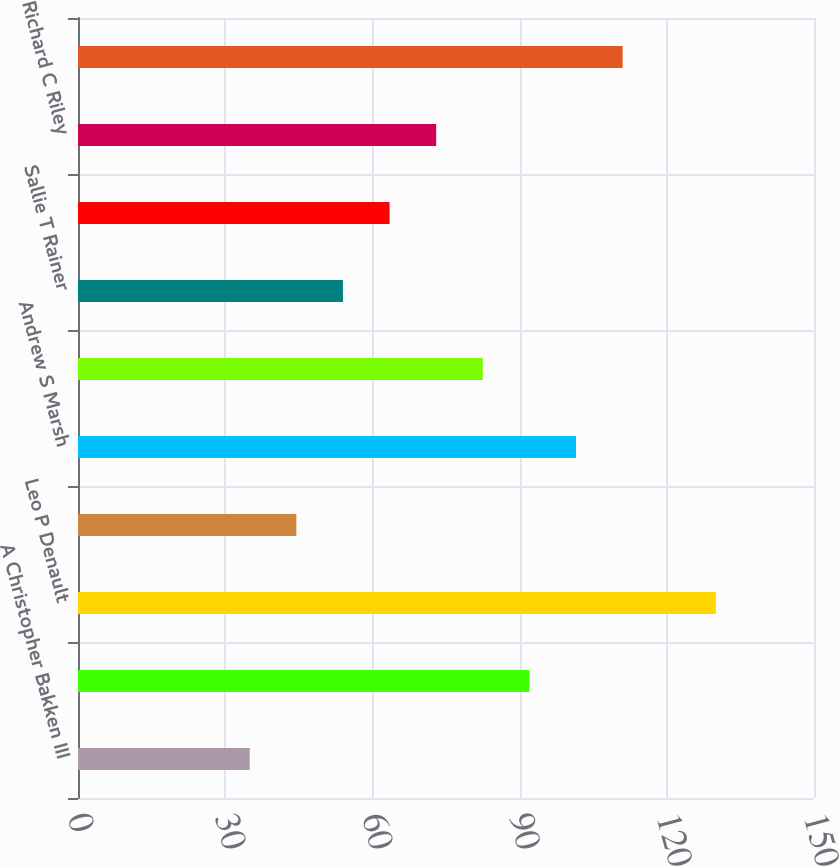Convert chart to OTSL. <chart><loc_0><loc_0><loc_500><loc_500><bar_chart><fcel>A Christopher Bakken III<fcel>Marcus V Brown<fcel>Leo P Denault<fcel>Haley R Fisackerly<fcel>Andrew S Marsh<fcel>Phillip R May Jr<fcel>Sallie T Rainer<fcel>Charles L Rice Jr<fcel>Richard C Riley<fcel>Roderick K West<nl><fcel>35<fcel>92<fcel>130<fcel>44.5<fcel>101.5<fcel>82.5<fcel>54<fcel>63.5<fcel>73<fcel>111<nl></chart> 